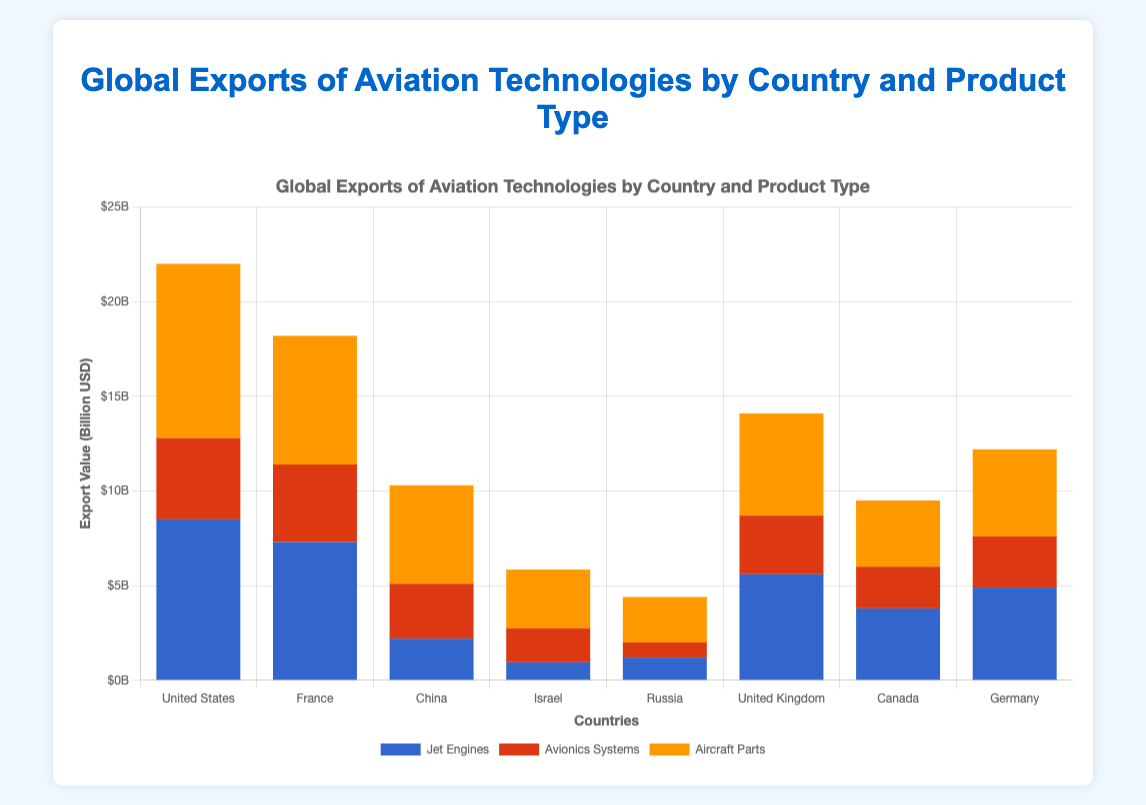Which country has the highest total export value for aviation technologies? Sum up the export values for each product type in all countries. The United States has the highest total (8500 + 4300 + 9200) = $22 billion.
Answer: United States Which product type has the highest export value for China? Compare the export values of Jet Engines, Avionics Systems, and Aircraft Parts for China. Aircraft Parts has the highest export value of $5.2 billion.
Answer: Aircraft Parts What is the total export value of Avionics Systems for France and Israel combined? Sum the export values of Avionics Systems for both countries: France $4.1 billion + Israel $1.8 billion = $5.9 billion.
Answer: $5.9B Which country exports more Jet Engines, Canada or Germany? Compare the export values of Jet Engines for both countries. Canada has $3.8 billion while Germany has $4.9 billion. Germany exports more.
Answer: Germany By how much does the total export value of Aircraft Parts from the United States exceed that of France? Calculate the difference between the export values of Aircraft Parts for both countries: $9.2 billion (United States) - $6.8 billion (France) = $2.4 billion.
Answer: $2.4B Which country has the lowest total export value? Sum the export values for all product types in each country and find the minimum value. Israel's total is $0.95B (Jet Engines) + $1.8B (Avionics Systems) + $3.1B (Aircraft Parts) = $5.85B, which is the lowest among all countries.
Answer: Israel How many more billions does Russia earn from exporting Jet Engines compared to Avionics Systems? Calculate the difference between the export values of these two products for Russia: $1.2 billion (Jet Engines) - $0.8 billion (Avionics Systems) = $0.4 billion.
Answer: $0.4B Which product type is represented by the blue color in the chart? Look at the color coding for product types indicated in the legend. The blue color represents Jet Engines.
Answer: Jet Engines What is the combined export value of Aircraft Parts from France and the United Kingdom? Sum the export values of Aircraft Parts for both countries: $6.8 billion (France) + $5.4 billion (United Kingdom) = $12.2 billion.
Answer: $12.2B Which country has the largest export value difference between Avionics Systems and Jet Engines? Calculate the difference for each country and find the largest one. The United States has the largest difference: $8.5B (Jet Engines) - $4.3B (Avionics Systems) = $4.2 billion.
Answer: United States 